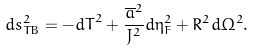Convert formula to latex. <formula><loc_0><loc_0><loc_500><loc_500>d s _ { T B } ^ { 2 } = - { d T } ^ { 2 } + \frac { { \overline { a } } ^ { 2 } } { J ^ { 2 } } d { \eta } _ { F } ^ { 2 } + R ^ { 2 } d { \Omega } ^ { 2 } .</formula> 